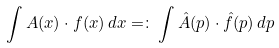<formula> <loc_0><loc_0><loc_500><loc_500>\int A ( x ) \cdot f ( x ) \, d x = \colon \int \hat { A } ( p ) \cdot \hat { f } ( p ) \, d p</formula> 